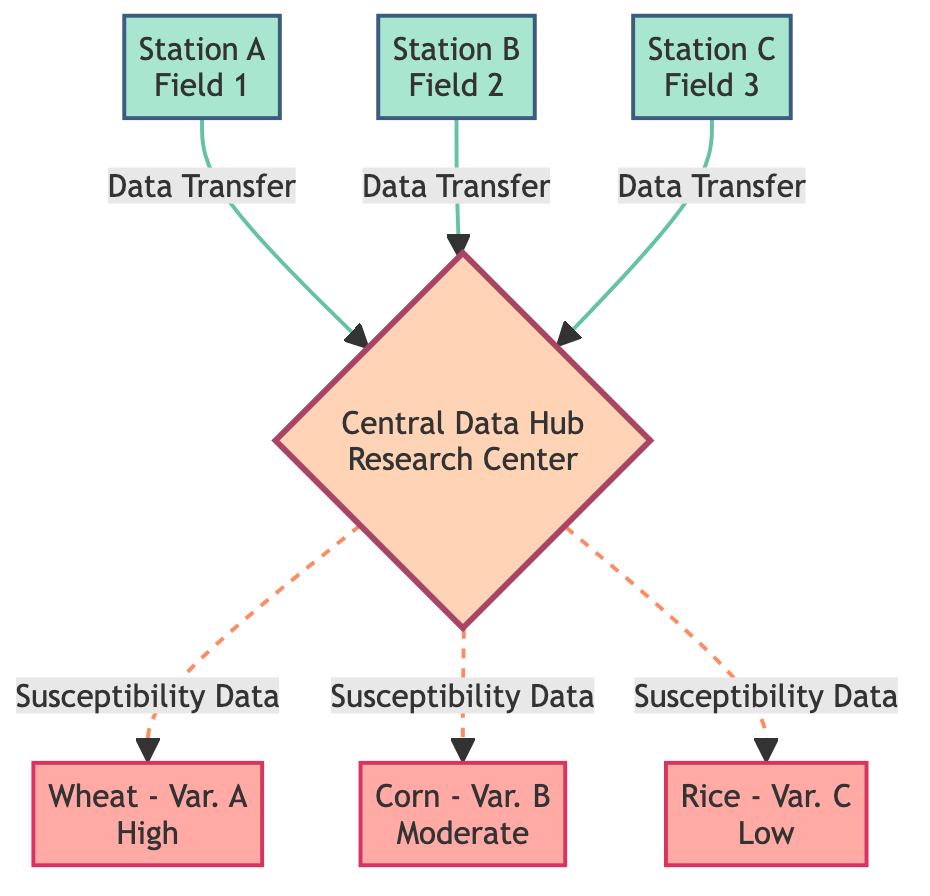How many monitoring stations are shown in the diagram? The diagram lists three monitoring stations: Station A, Station B, and Station C. Therefore, counting these nodes gives the answer.
Answer: 3 What type of data is transferred from the monitoring stations to the central hub? The edges connecting each monitoring station to the central hub are labeled "Data Transfer," indicating the nature of the data being transferred.
Answer: Data Transfer Which crop variety has a high susceptibility to pests and diseases? The central hub connects with "Wheat - Var. A" and is labeled as having "High" susceptibility on the edge from the hub. This indicates which crop variety is highly susceptible.
Answer: Wheat - Var. A Which monitoring station is located in Field 3? By checking the node labels, Station C is identified as being located in Field 3. This information is straightforward as the node labels provide their locations directly.
Answer: Station C How many connections lead from the central hub to crop varieties? The central hub has three edges connecting it to the crop varieties (Wheat - Var. A, Corn - Var. B, Rice - Var. C). Counting these edges provides the total number of connections.
Answer: 3 Which crop variety mentioned has moderate susceptibility? By reviewing the edges connected to the central hub, "Corn - Var. B" is indicated to have "Moderate" susceptibility, as mentioned in the edge labels.
Answer: Corn - Var. B What is the role of the central hub in this network? The central hub acts as a data aggregator, receiving data from the monitoring stations and distributing susceptibility data to the crop varieties. Hence, its role is pivotal in connecting different nodes.
Answer: Central Data Hub Which field is Station A located in? Directly referencing the node information, Station A is labeled as being located in Field 1, which specifies its geographic placement.
Answer: Field 1 What is the relationship between the central hub and the crop varieties? The connection from the central hub to each crop variety is labeled "Susceptibility Data," indicating that the hub provides this specific type of data relating to pest and disease susceptibility.
Answer: Susceptibility Data 